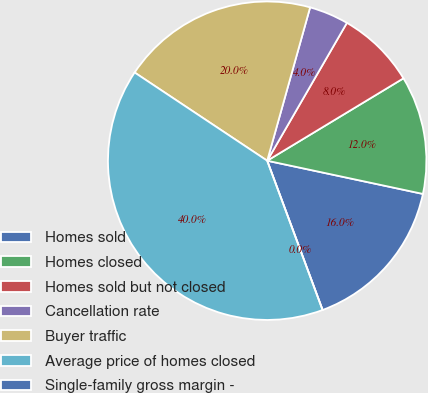Convert chart. <chart><loc_0><loc_0><loc_500><loc_500><pie_chart><fcel>Homes sold<fcel>Homes closed<fcel>Homes sold but not closed<fcel>Cancellation rate<fcel>Buyer traffic<fcel>Average price of homes closed<fcel>Single-family gross margin -<nl><fcel>16.0%<fcel>12.0%<fcel>8.0%<fcel>4.0%<fcel>20.0%<fcel>40.0%<fcel>0.0%<nl></chart> 